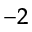Convert formula to latex. <formula><loc_0><loc_0><loc_500><loc_500>^ { - 2 }</formula> 